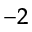Convert formula to latex. <formula><loc_0><loc_0><loc_500><loc_500>^ { - 2 }</formula> 